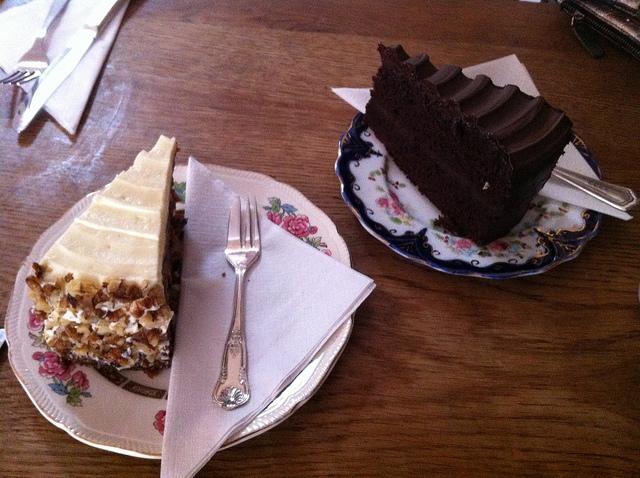Which cake has chocolate frosting?
Be succinct. Right. What material does this table appear to be made from?
Keep it brief. Wood. What is the fork made out of?
Answer briefly. Metal. Is there a knife on the napkin closest to the cake?
Write a very short answer. No. 